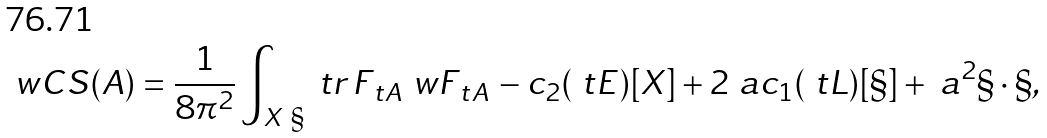Convert formula to latex. <formula><loc_0><loc_0><loc_500><loc_500>\ w C S ( A ) = \frac { 1 } { 8 \pi ^ { 2 } } \int _ { X \ \S } \ t r \, F _ { \ t A } \ w F _ { \ t A } \, - c _ { 2 } ( \ t E ) [ X ] + 2 \ a c _ { 1 } ( \ t L ) [ \S ] + \ a ^ { 2 } \S \cdot \S ,</formula> 